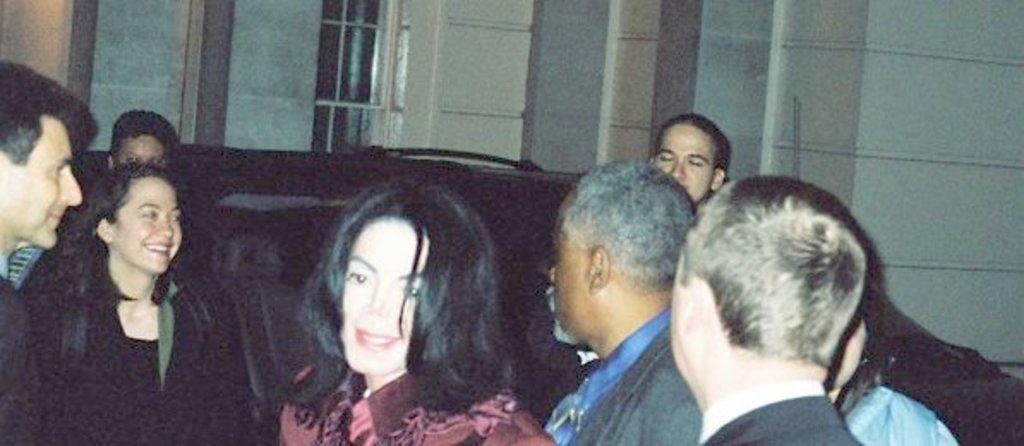Who is present in the image? There are women in the image. What are the women doing in the image? The women are standing in the front. What can be seen behind the women? There is a car behind the women. What is visible in the background of the image? There is a building visible in the background. What type of soup is being served in the image? There is no soup present in the image. Is there a battle taking place in the image? There is no battle depicted in the image. 